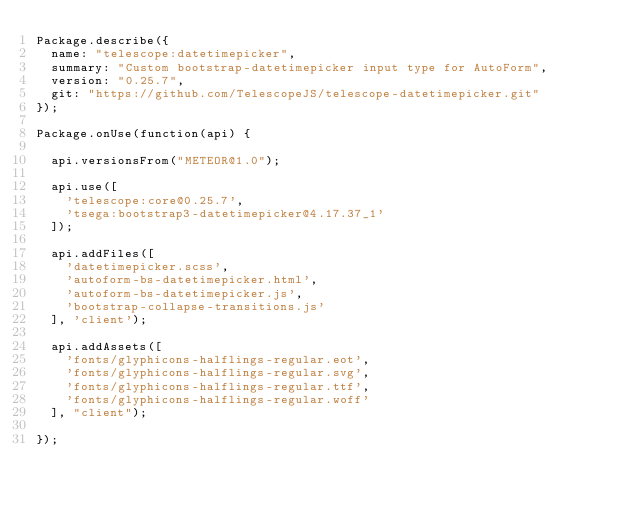Convert code to text. <code><loc_0><loc_0><loc_500><loc_500><_JavaScript_>Package.describe({
  name: "telescope:datetimepicker",
  summary: "Custom bootstrap-datetimepicker input type for AutoForm",
  version: "0.25.7",
  git: "https://github.com/TelescopeJS/telescope-datetimepicker.git"
});

Package.onUse(function(api) {

  api.versionsFrom("METEOR@1.0");

  api.use([
    'telescope:core@0.25.7',
    'tsega:bootstrap3-datetimepicker@4.17.37_1'
  ]);

  api.addFiles([
    'datetimepicker.scss',
    'autoform-bs-datetimepicker.html',
    'autoform-bs-datetimepicker.js',
    'bootstrap-collapse-transitions.js'
  ], 'client');

  api.addAssets([
    'fonts/glyphicons-halflings-regular.eot',
    'fonts/glyphicons-halflings-regular.svg',
    'fonts/glyphicons-halflings-regular.ttf',
    'fonts/glyphicons-halflings-regular.woff'
  ], "client");

});
</code> 